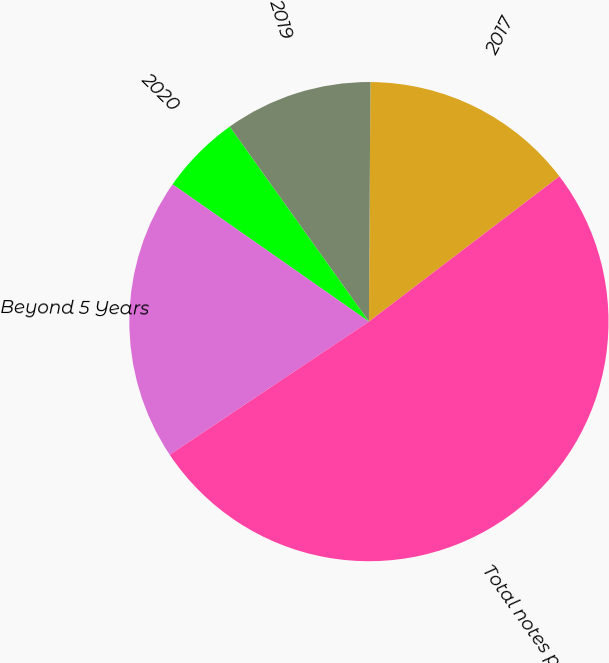<chart> <loc_0><loc_0><loc_500><loc_500><pie_chart><fcel>2017<fcel>2019<fcel>2020<fcel>Beyond 5 Years<fcel>Total notes payable<nl><fcel>14.53%<fcel>9.97%<fcel>5.42%<fcel>19.09%<fcel>50.99%<nl></chart> 